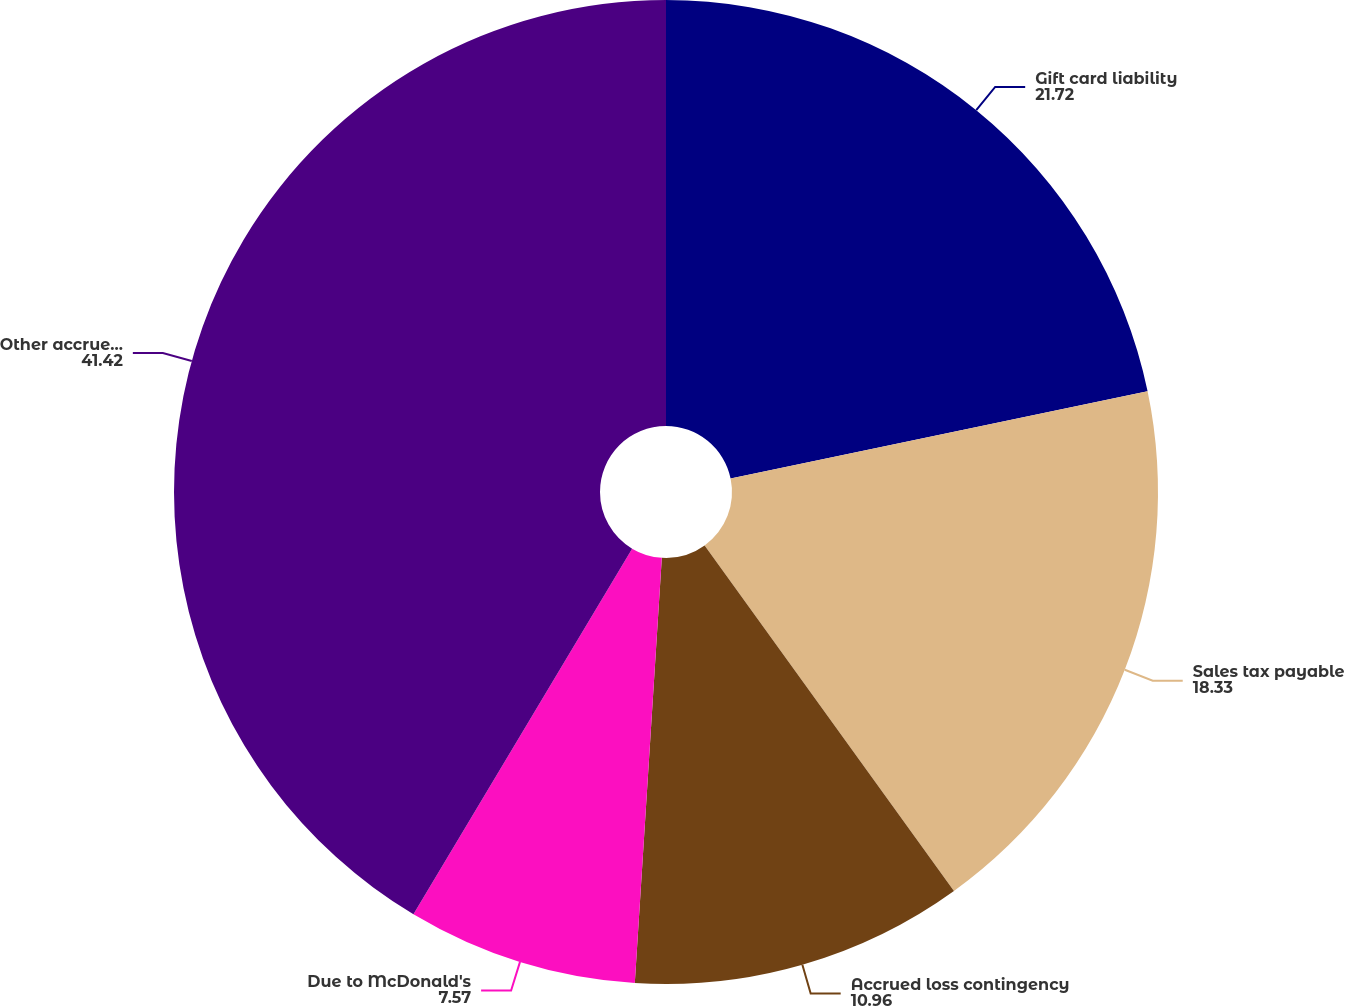Convert chart to OTSL. <chart><loc_0><loc_0><loc_500><loc_500><pie_chart><fcel>Gift card liability<fcel>Sales tax payable<fcel>Accrued loss contingency<fcel>Due to McDonald's<fcel>Other accrued expenses<nl><fcel>21.72%<fcel>18.33%<fcel>10.96%<fcel>7.57%<fcel>41.42%<nl></chart> 